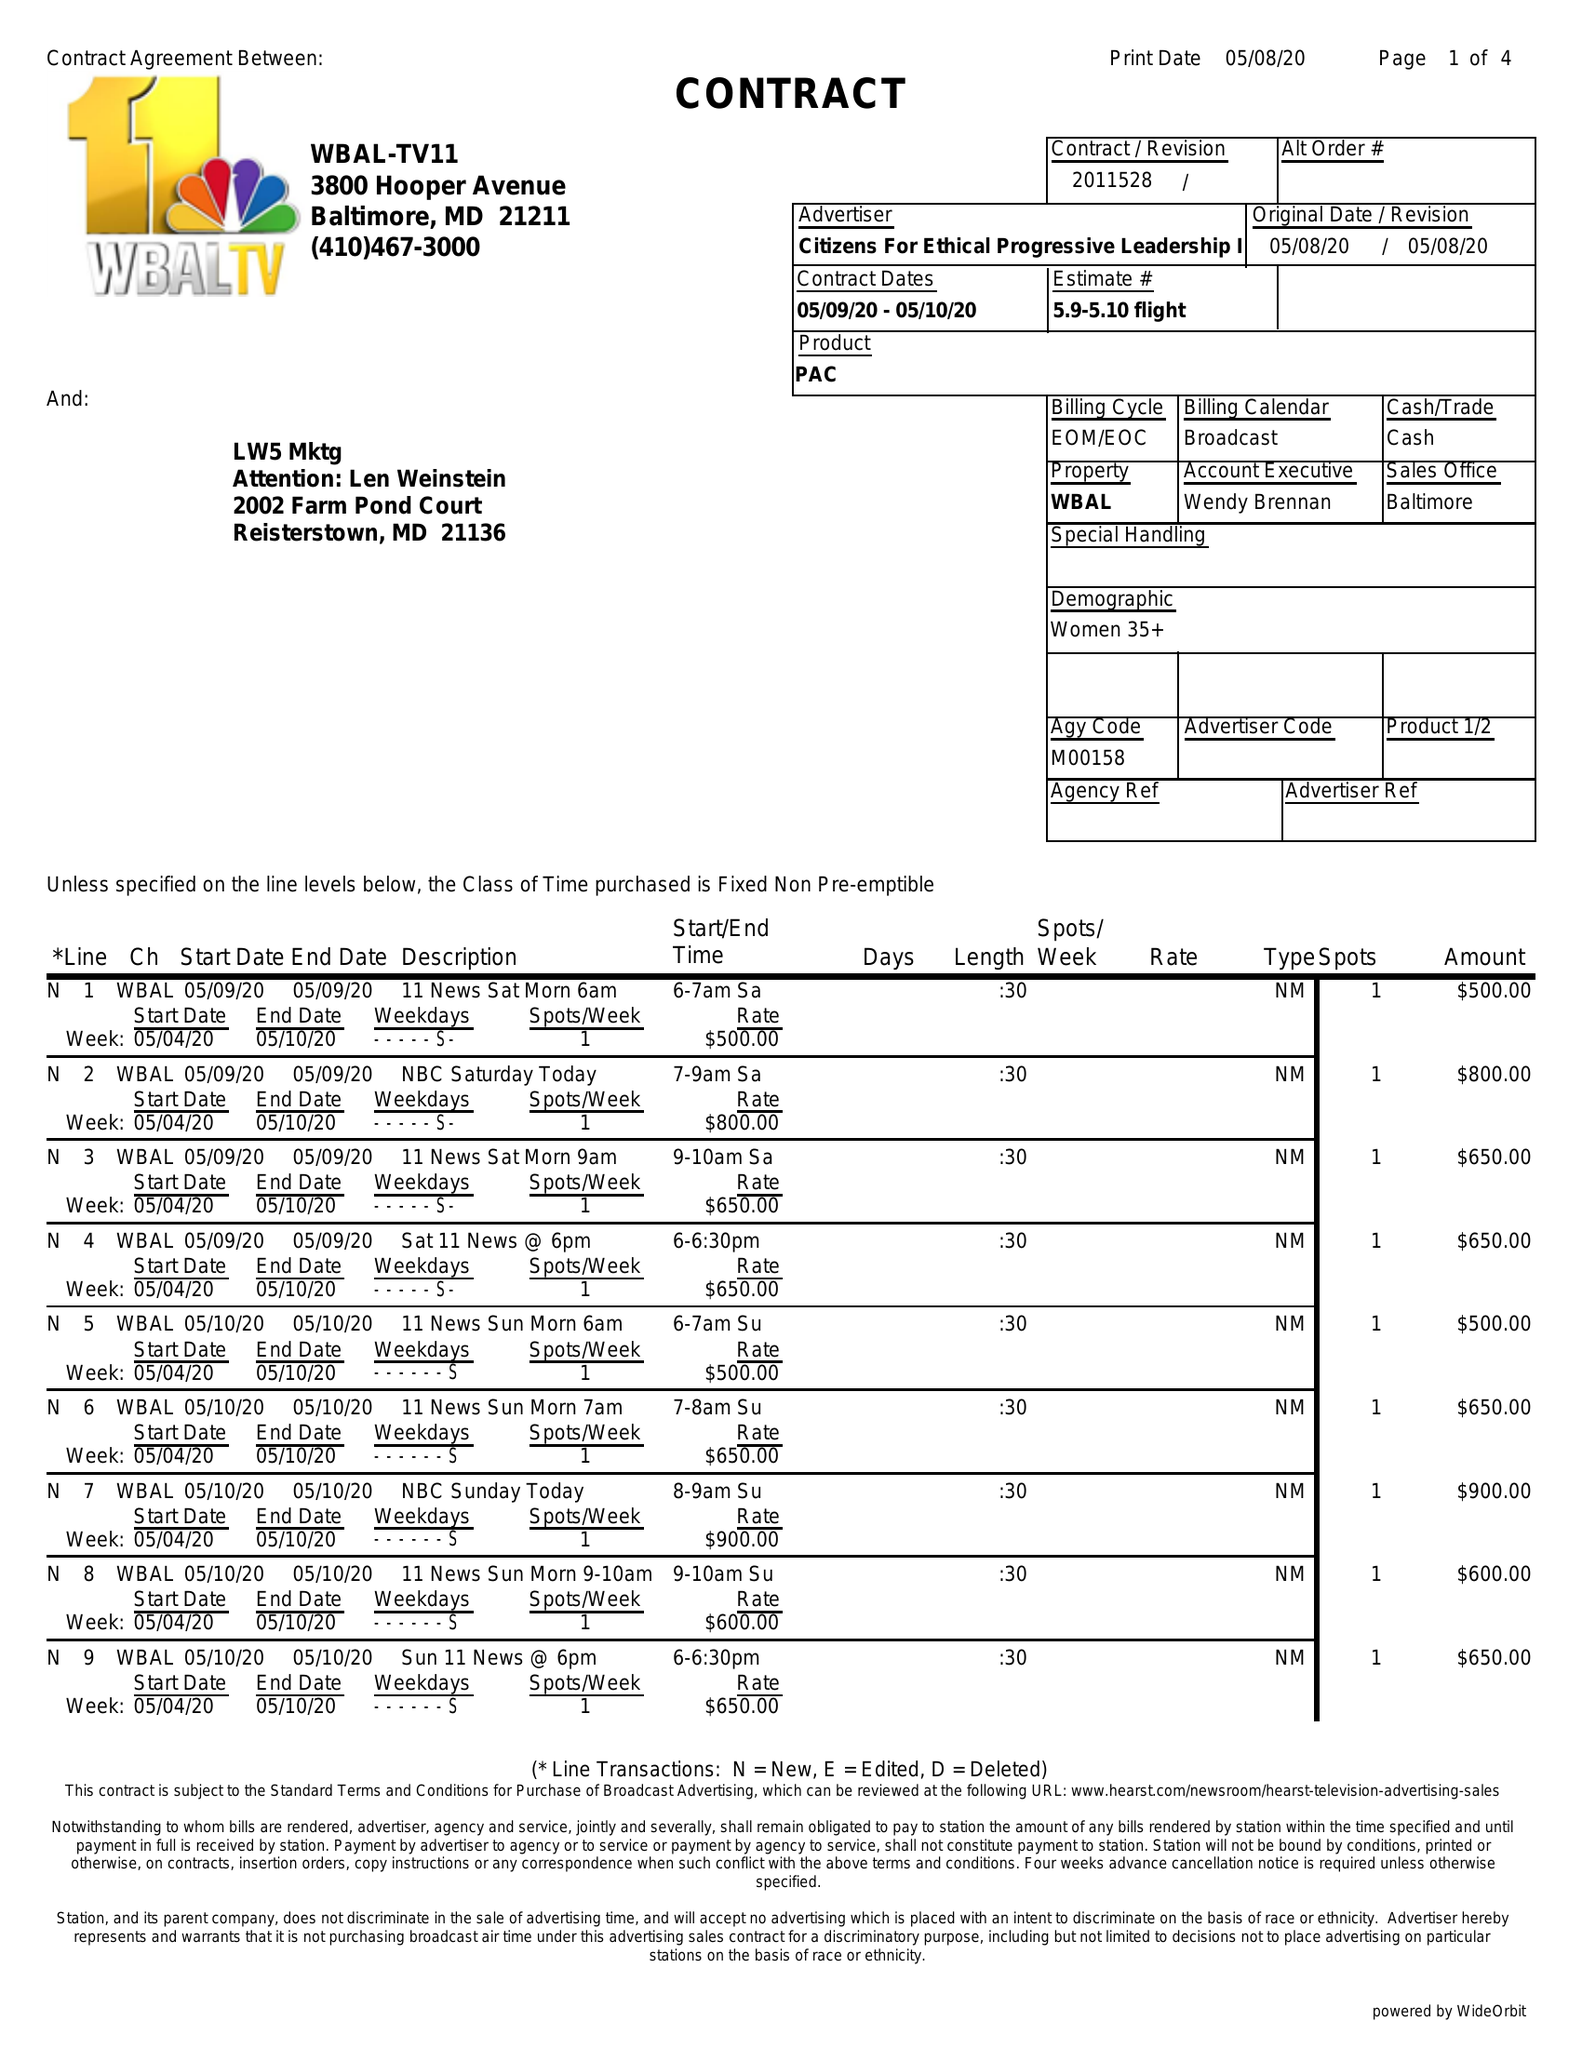What is the value for the flight_from?
Answer the question using a single word or phrase. 05/09/20 